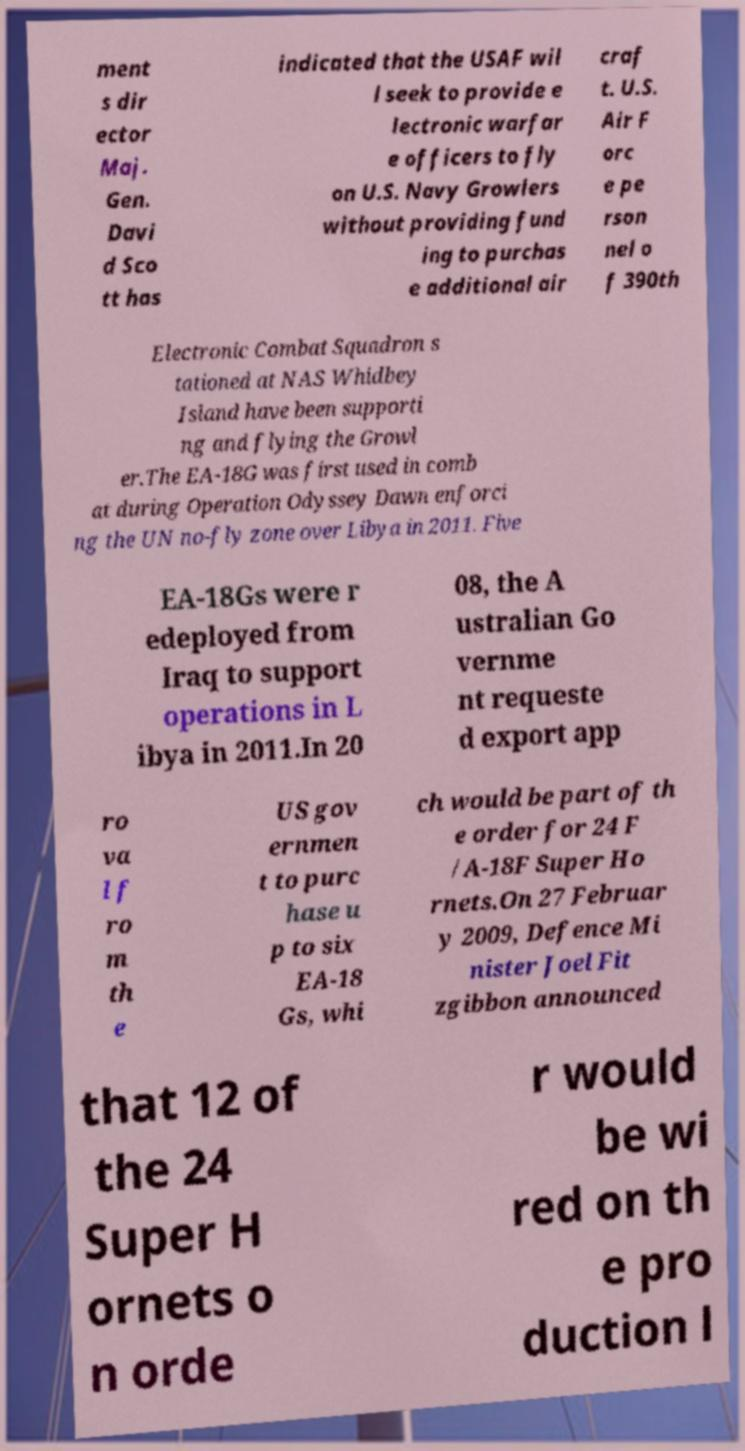For documentation purposes, I need the text within this image transcribed. Could you provide that? ment s dir ector Maj. Gen. Davi d Sco tt has indicated that the USAF wil l seek to provide e lectronic warfar e officers to fly on U.S. Navy Growlers without providing fund ing to purchas e additional air craf t. U.S. Air F orc e pe rson nel o f 390th Electronic Combat Squadron s tationed at NAS Whidbey Island have been supporti ng and flying the Growl er.The EA-18G was first used in comb at during Operation Odyssey Dawn enforci ng the UN no-fly zone over Libya in 2011. Five EA-18Gs were r edeployed from Iraq to support operations in L ibya in 2011.In 20 08, the A ustralian Go vernme nt requeste d export app ro va l f ro m th e US gov ernmen t to purc hase u p to six EA-18 Gs, whi ch would be part of th e order for 24 F /A-18F Super Ho rnets.On 27 Februar y 2009, Defence Mi nister Joel Fit zgibbon announced that 12 of the 24 Super H ornets o n orde r would be wi red on th e pro duction l 